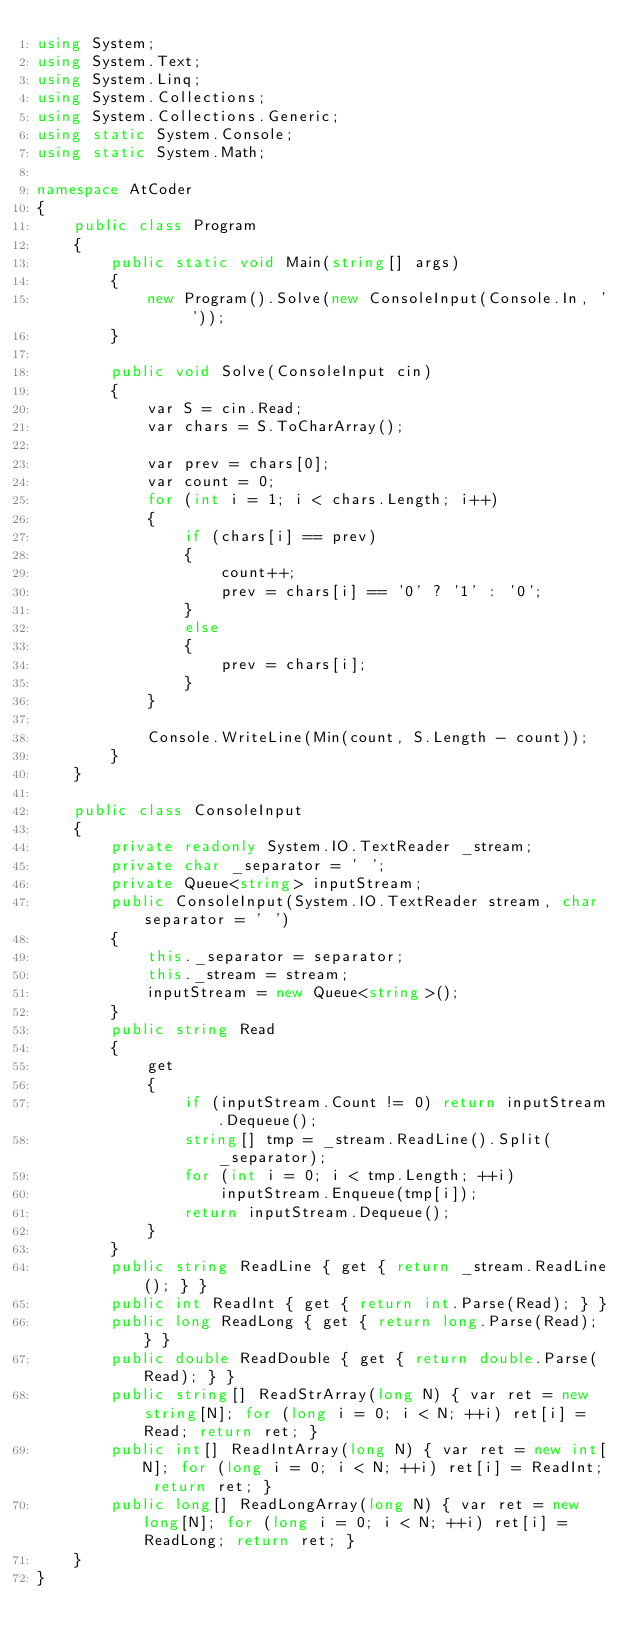<code> <loc_0><loc_0><loc_500><loc_500><_C#_>using System;
using System.Text;
using System.Linq;
using System.Collections;
using System.Collections.Generic;
using static System.Console;
using static System.Math;

namespace AtCoder
{
    public class Program
    {
        public static void Main(string[] args)
        {
            new Program().Solve(new ConsoleInput(Console.In, ' '));
        }

        public void Solve(ConsoleInput cin)
        {
            var S = cin.Read;
            var chars = S.ToCharArray();

            var prev = chars[0];
            var count = 0;
            for (int i = 1; i < chars.Length; i++)
            {
                if (chars[i] == prev)
                {
                    count++;
                    prev = chars[i] == '0' ? '1' : '0';
                }
                else
                {
                    prev = chars[i];
                }
            }

            Console.WriteLine(Min(count, S.Length - count));
        }
    }

    public class ConsoleInput
    {
        private readonly System.IO.TextReader _stream;
        private char _separator = ' ';
        private Queue<string> inputStream;
        public ConsoleInput(System.IO.TextReader stream, char separator = ' ')
        {
            this._separator = separator;
            this._stream = stream;
            inputStream = new Queue<string>();
        }
        public string Read
        {
            get
            {
                if (inputStream.Count != 0) return inputStream.Dequeue();
                string[] tmp = _stream.ReadLine().Split(_separator);
                for (int i = 0; i < tmp.Length; ++i)
                    inputStream.Enqueue(tmp[i]);
                return inputStream.Dequeue();
            }
        }
        public string ReadLine { get { return _stream.ReadLine(); } }
        public int ReadInt { get { return int.Parse(Read); } }
        public long ReadLong { get { return long.Parse(Read); } }
        public double ReadDouble { get { return double.Parse(Read); } }
        public string[] ReadStrArray(long N) { var ret = new string[N]; for (long i = 0; i < N; ++i) ret[i] = Read; return ret; }
        public int[] ReadIntArray(long N) { var ret = new int[N]; for (long i = 0; i < N; ++i) ret[i] = ReadInt; return ret; }
        public long[] ReadLongArray(long N) { var ret = new long[N]; for (long i = 0; i < N; ++i) ret[i] = ReadLong; return ret; }
    }
}</code> 